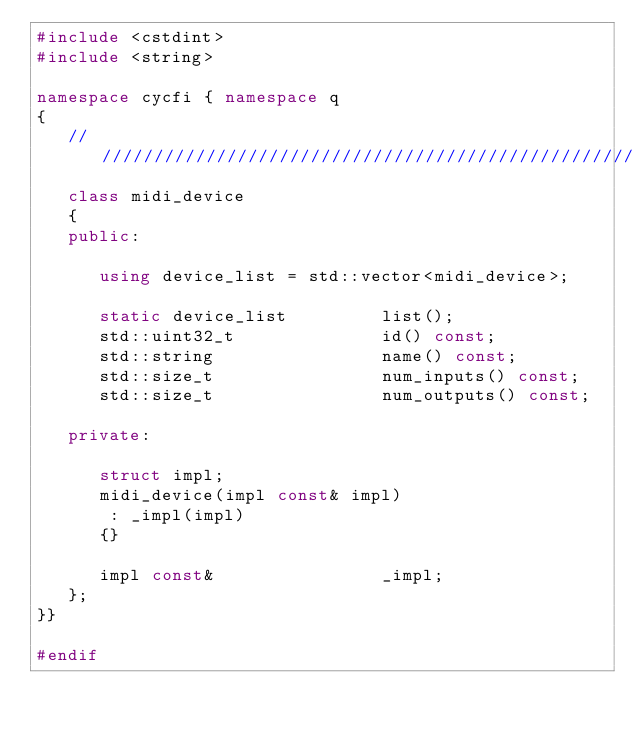Convert code to text. <code><loc_0><loc_0><loc_500><loc_500><_C++_>#include <cstdint>
#include <string>

namespace cycfi { namespace q
{
   ////////////////////////////////////////////////////////////////////////////
   class midi_device
   {
   public:

      using device_list = std::vector<midi_device>;

      static device_list         list();
      std::uint32_t              id() const;
      std::string                name() const;
      std::size_t                num_inputs() const;
      std::size_t                num_outputs() const;

   private:

      struct impl;
      midi_device(impl const& impl)
       : _impl(impl)
      {}

      impl const&                _impl;
   };
}}

#endif</code> 